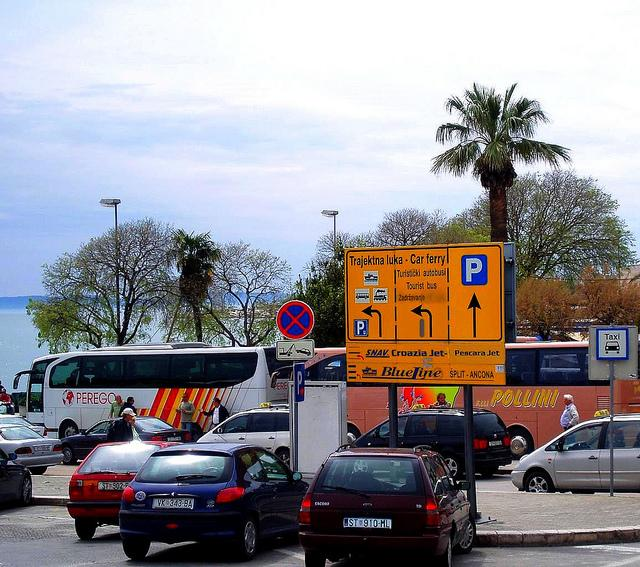How might cars cross the water seen here? Please explain your reasoning. ferry boat. Boats are parked at a marina. 